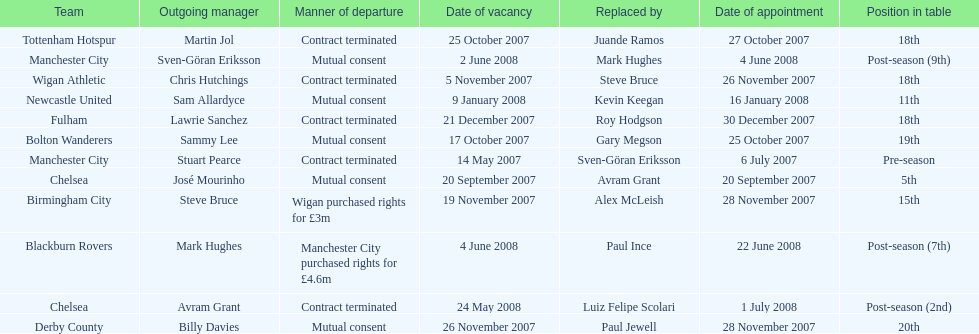Which new manager was purchased for the most money in the 2007-08 premier league season? Mark Hughes. 